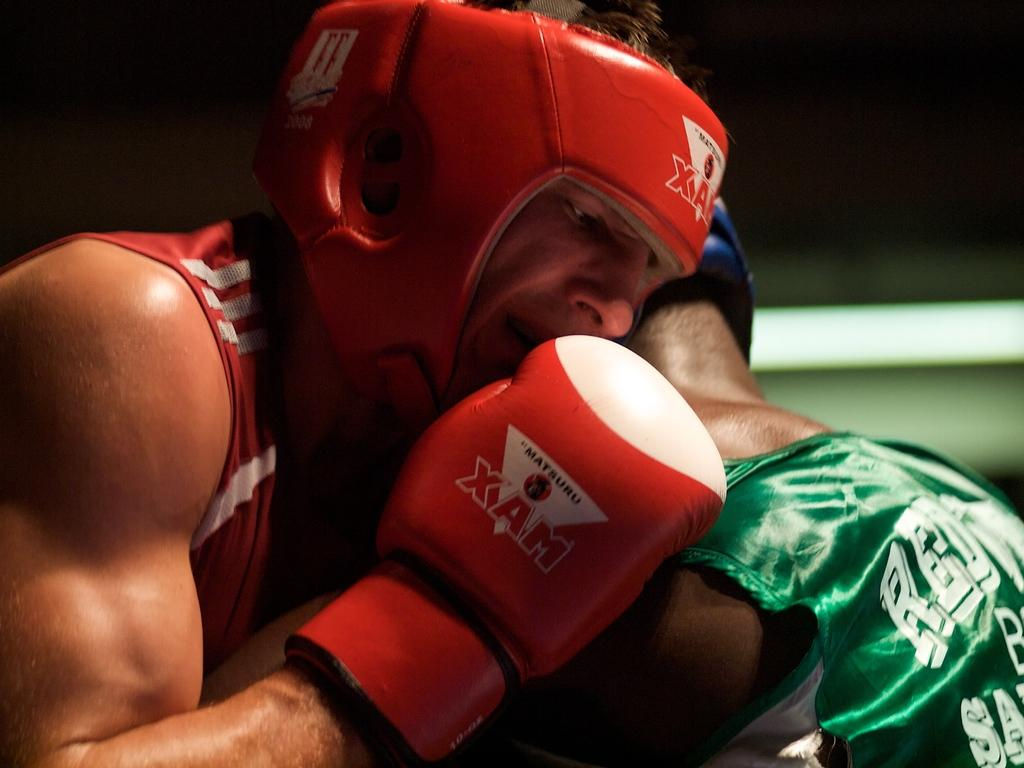<image>
Share a concise interpretation of the image provided. A boxing match is going on and the boxers are in a clinch with gloves that say Matsuru Xam. 